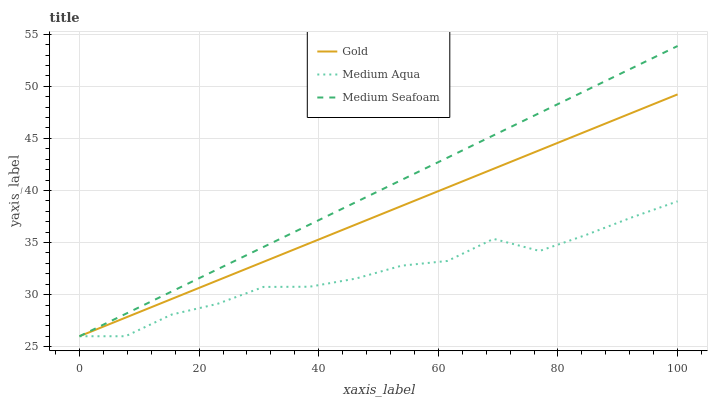Does Medium Aqua have the minimum area under the curve?
Answer yes or no. Yes. Does Medium Seafoam have the maximum area under the curve?
Answer yes or no. Yes. Does Gold have the minimum area under the curve?
Answer yes or no. No. Does Gold have the maximum area under the curve?
Answer yes or no. No. Is Medium Seafoam the smoothest?
Answer yes or no. Yes. Is Medium Aqua the roughest?
Answer yes or no. Yes. Is Gold the smoothest?
Answer yes or no. No. Is Gold the roughest?
Answer yes or no. No. Does Medium Aqua have the lowest value?
Answer yes or no. Yes. Does Medium Seafoam have the highest value?
Answer yes or no. Yes. Does Gold have the highest value?
Answer yes or no. No. Does Gold intersect Medium Aqua?
Answer yes or no. Yes. Is Gold less than Medium Aqua?
Answer yes or no. No. Is Gold greater than Medium Aqua?
Answer yes or no. No. 